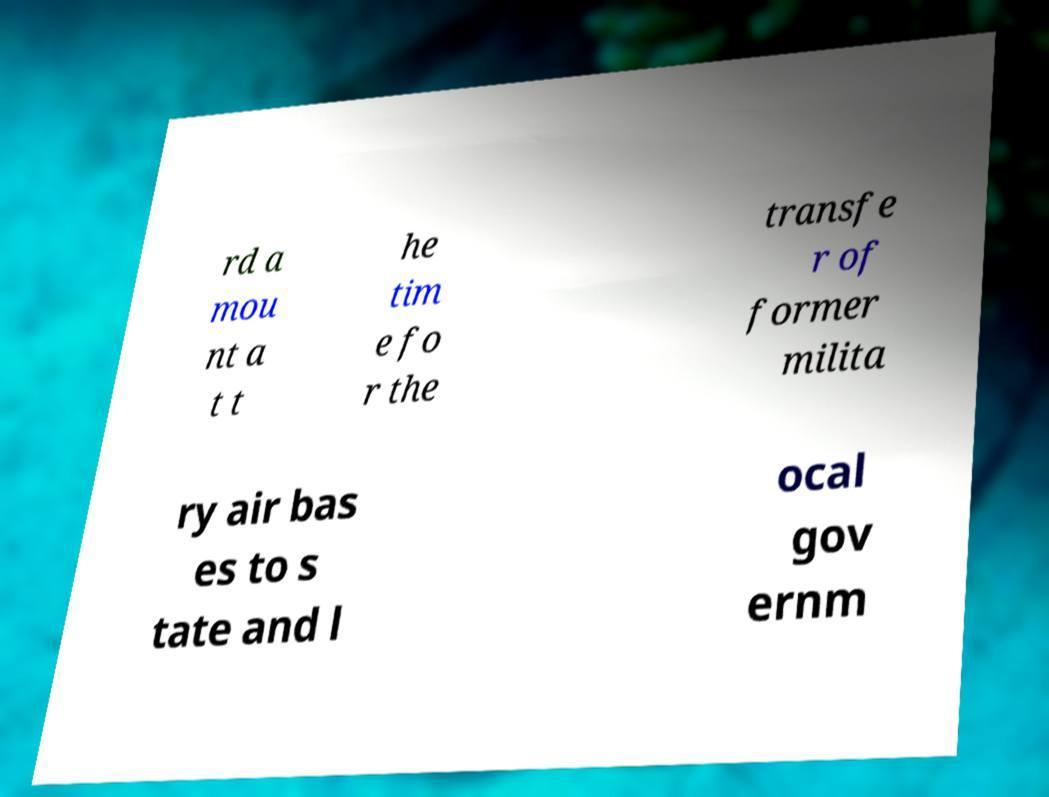Could you extract and type out the text from this image? rd a mou nt a t t he tim e fo r the transfe r of former milita ry air bas es to s tate and l ocal gov ernm 